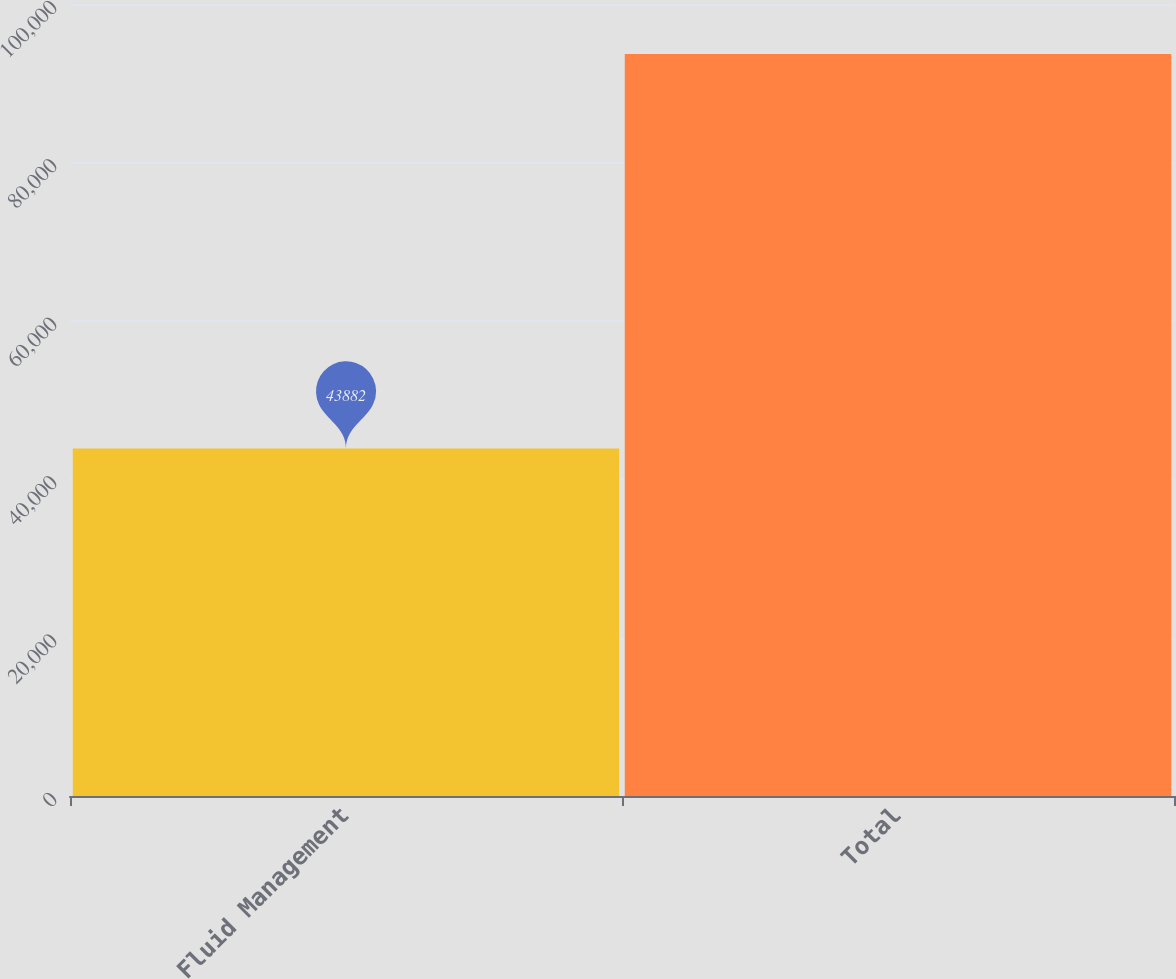Convert chart to OTSL. <chart><loc_0><loc_0><loc_500><loc_500><bar_chart><fcel>Fluid Management<fcel>Total<nl><fcel>43882<fcel>93689<nl></chart> 